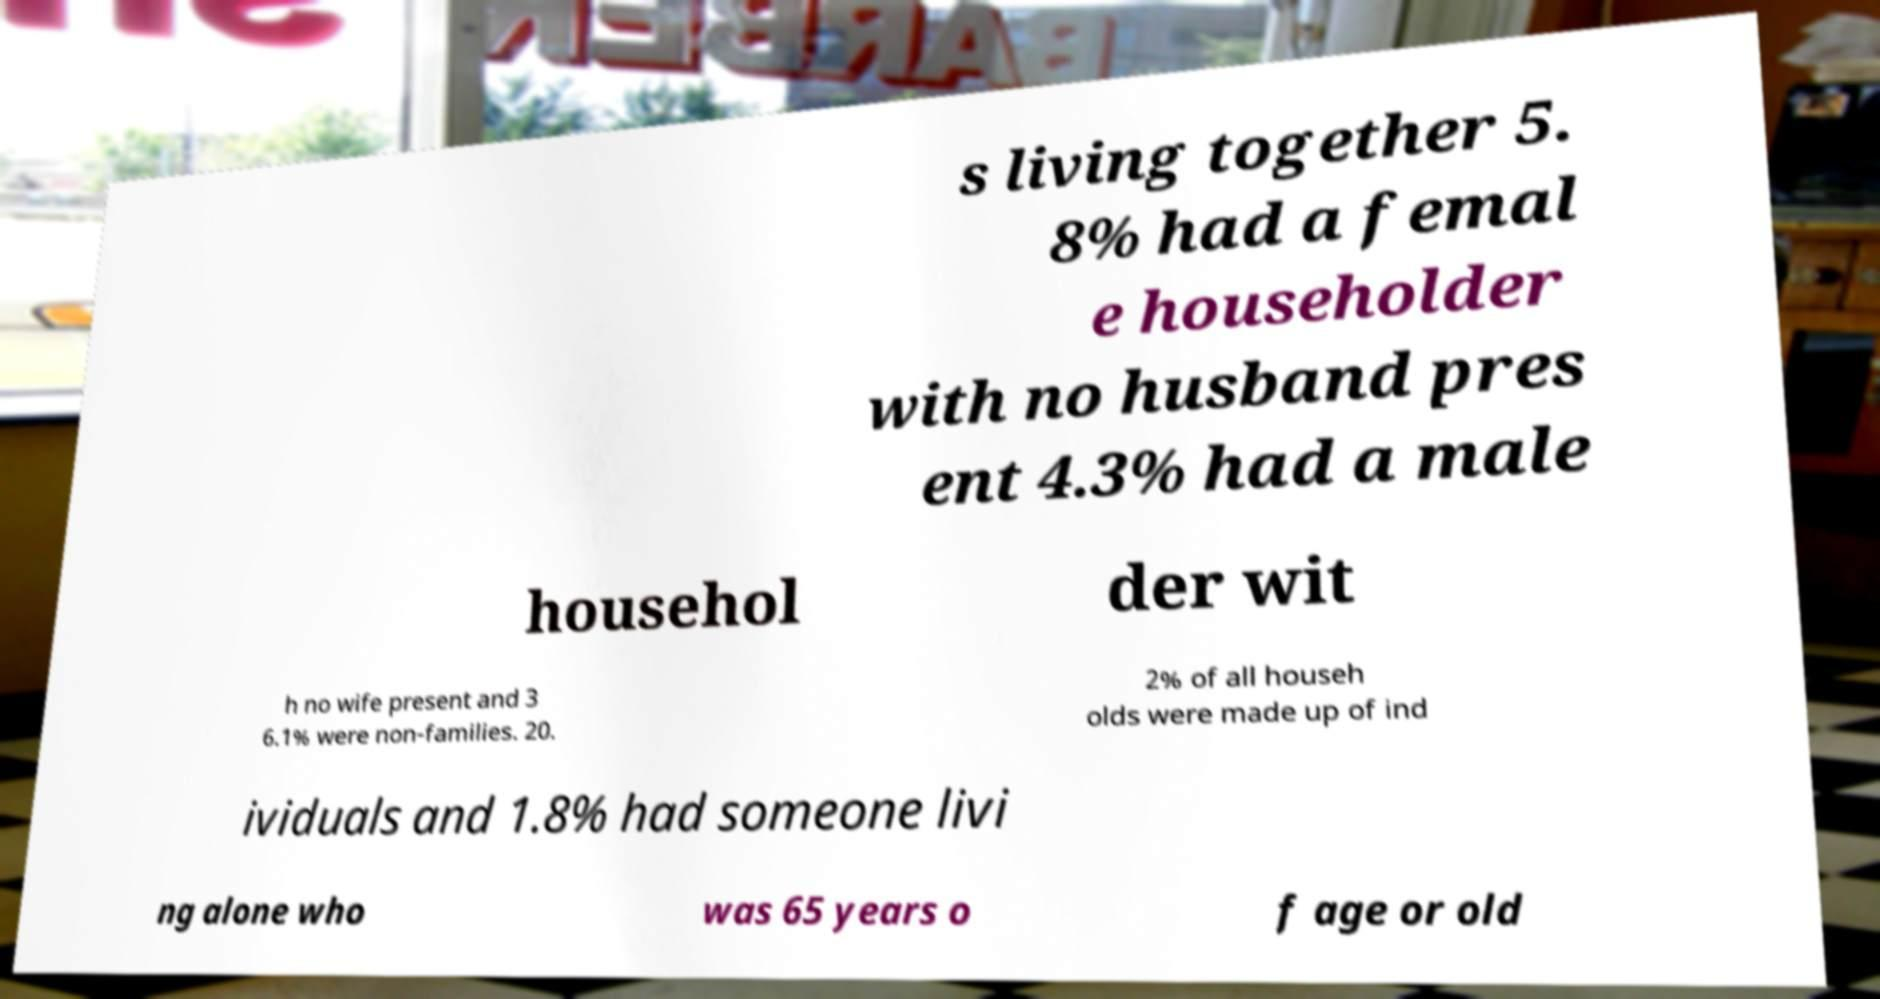Can you accurately transcribe the text from the provided image for me? s living together 5. 8% had a femal e householder with no husband pres ent 4.3% had a male househol der wit h no wife present and 3 6.1% were non-families. 20. 2% of all househ olds were made up of ind ividuals and 1.8% had someone livi ng alone who was 65 years o f age or old 